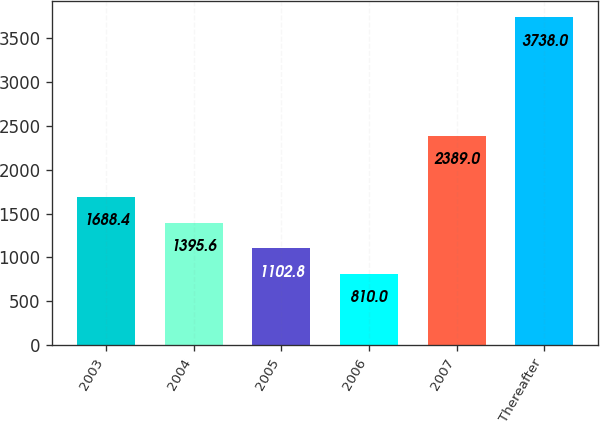<chart> <loc_0><loc_0><loc_500><loc_500><bar_chart><fcel>2003<fcel>2004<fcel>2005<fcel>2006<fcel>2007<fcel>Thereafter<nl><fcel>1688.4<fcel>1395.6<fcel>1102.8<fcel>810<fcel>2389<fcel>3738<nl></chart> 